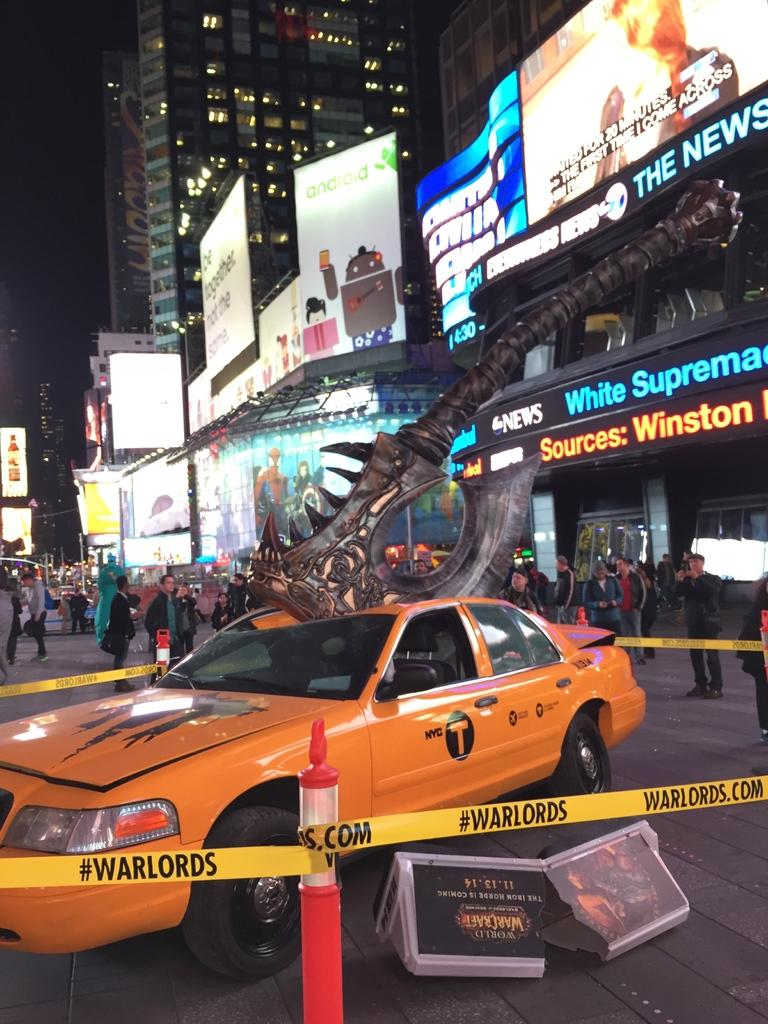<image>
Relay a brief, clear account of the picture shown. An orange taxi is parked near yellow tape advertising warlords.com. 